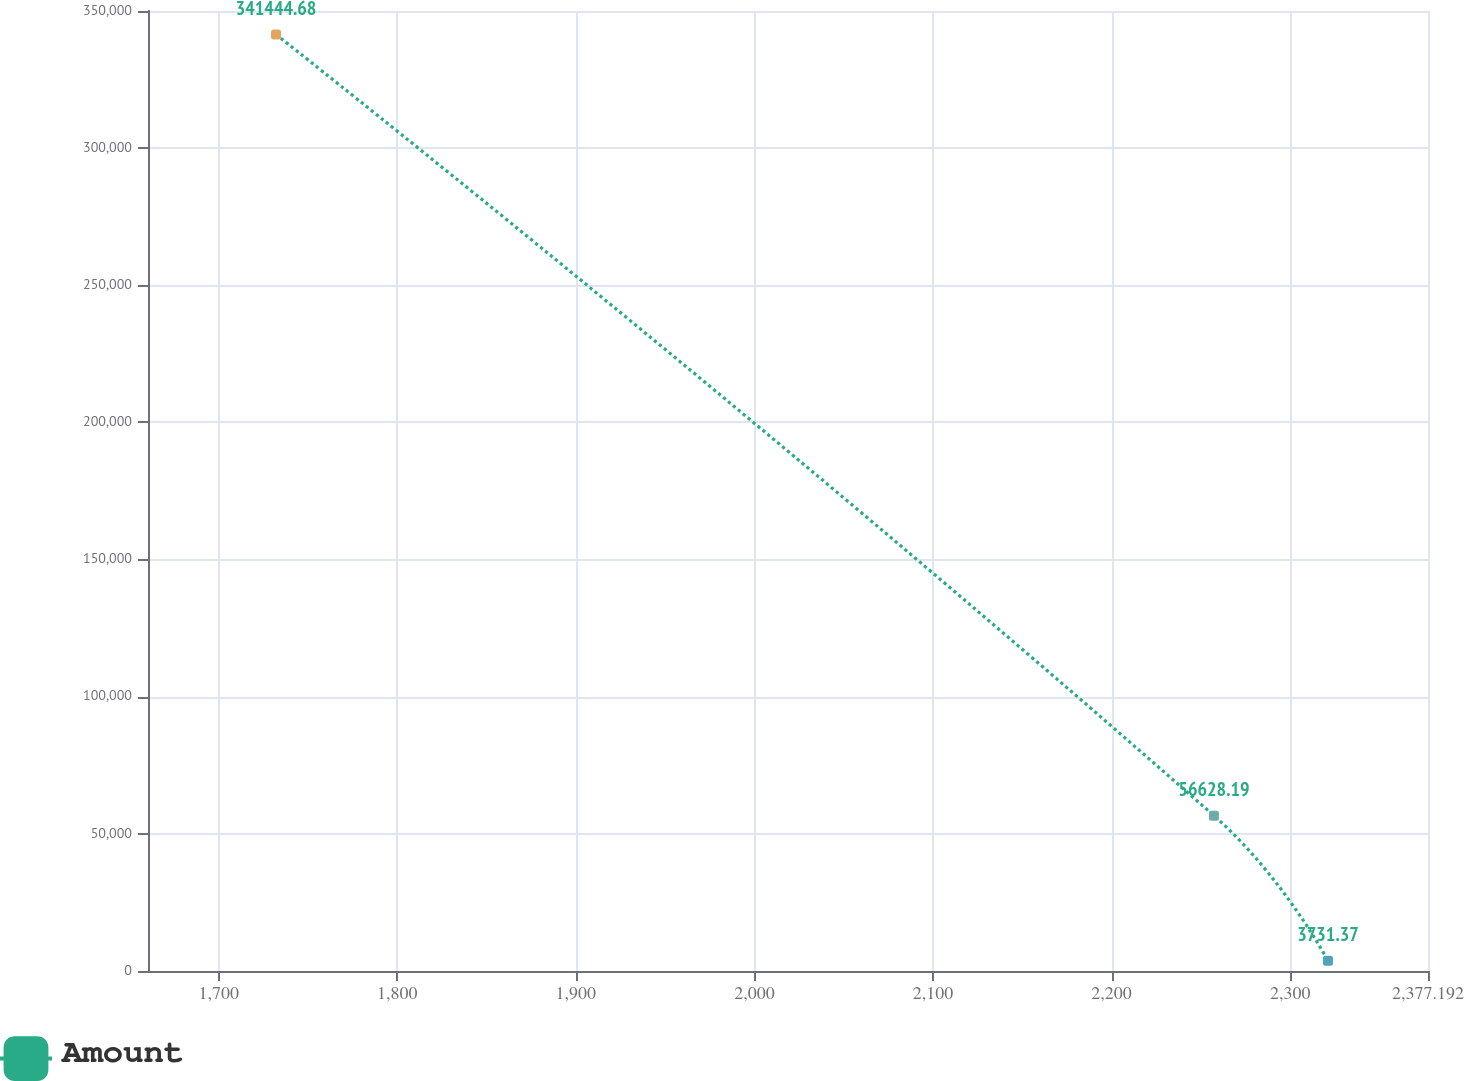Convert chart. <chart><loc_0><loc_0><loc_500><loc_500><line_chart><ecel><fcel>Amount<nl><fcel>1732.09<fcel>341445<nl><fcel>2257.32<fcel>56628.2<nl><fcel>2321.17<fcel>3731.37<nl><fcel>2385.02<fcel>532700<nl><fcel>2448.87<fcel>253976<nl></chart> 